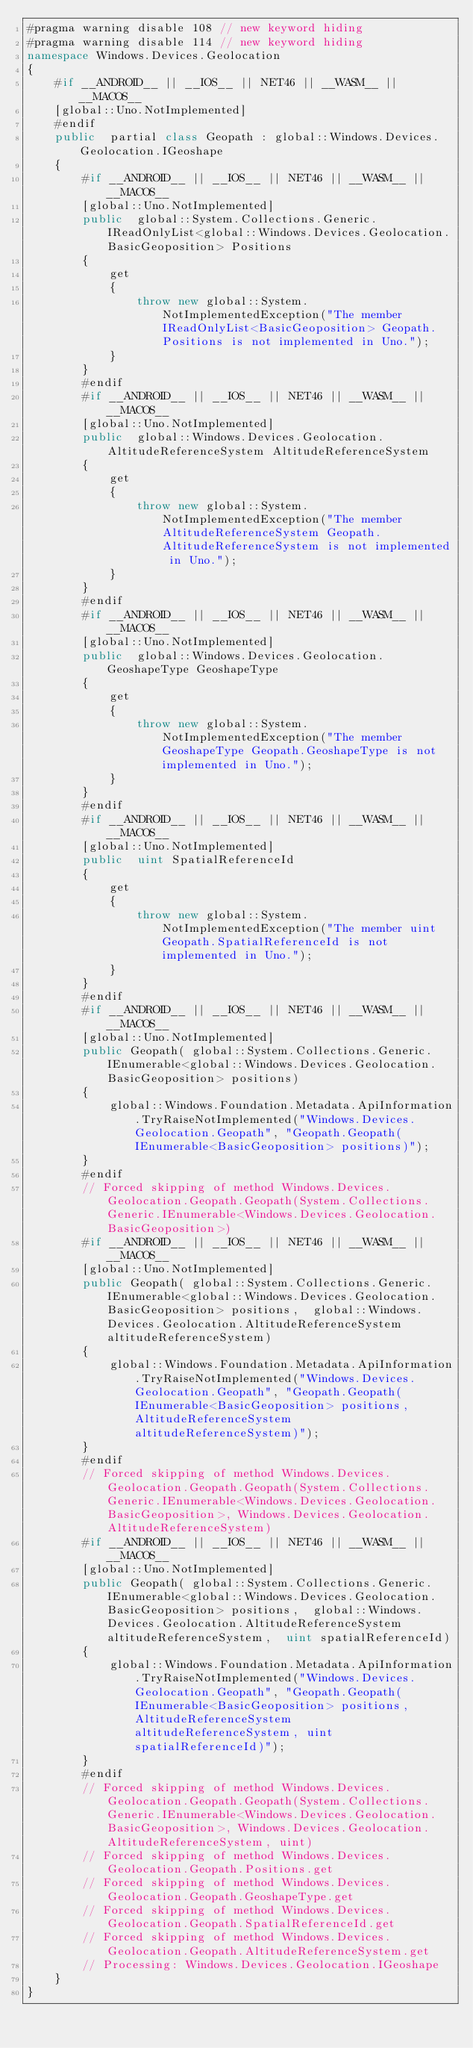Convert code to text. <code><loc_0><loc_0><loc_500><loc_500><_C#_>#pragma warning disable 108 // new keyword hiding
#pragma warning disable 114 // new keyword hiding
namespace Windows.Devices.Geolocation
{
	#if __ANDROID__ || __IOS__ || NET46 || __WASM__ || __MACOS__
	[global::Uno.NotImplemented]
	#endif
	public  partial class Geopath : global::Windows.Devices.Geolocation.IGeoshape
	{
		#if __ANDROID__ || __IOS__ || NET46 || __WASM__ || __MACOS__
		[global::Uno.NotImplemented]
		public  global::System.Collections.Generic.IReadOnlyList<global::Windows.Devices.Geolocation.BasicGeoposition> Positions
		{
			get
			{
				throw new global::System.NotImplementedException("The member IReadOnlyList<BasicGeoposition> Geopath.Positions is not implemented in Uno.");
			}
		}
		#endif
		#if __ANDROID__ || __IOS__ || NET46 || __WASM__ || __MACOS__
		[global::Uno.NotImplemented]
		public  global::Windows.Devices.Geolocation.AltitudeReferenceSystem AltitudeReferenceSystem
		{
			get
			{
				throw new global::System.NotImplementedException("The member AltitudeReferenceSystem Geopath.AltitudeReferenceSystem is not implemented in Uno.");
			}
		}
		#endif
		#if __ANDROID__ || __IOS__ || NET46 || __WASM__ || __MACOS__
		[global::Uno.NotImplemented]
		public  global::Windows.Devices.Geolocation.GeoshapeType GeoshapeType
		{
			get
			{
				throw new global::System.NotImplementedException("The member GeoshapeType Geopath.GeoshapeType is not implemented in Uno.");
			}
		}
		#endif
		#if __ANDROID__ || __IOS__ || NET46 || __WASM__ || __MACOS__
		[global::Uno.NotImplemented]
		public  uint SpatialReferenceId
		{
			get
			{
				throw new global::System.NotImplementedException("The member uint Geopath.SpatialReferenceId is not implemented in Uno.");
			}
		}
		#endif
		#if __ANDROID__ || __IOS__ || NET46 || __WASM__ || __MACOS__
		[global::Uno.NotImplemented]
		public Geopath( global::System.Collections.Generic.IEnumerable<global::Windows.Devices.Geolocation.BasicGeoposition> positions) 
		{
			global::Windows.Foundation.Metadata.ApiInformation.TryRaiseNotImplemented("Windows.Devices.Geolocation.Geopath", "Geopath.Geopath(IEnumerable<BasicGeoposition> positions)");
		}
		#endif
		// Forced skipping of method Windows.Devices.Geolocation.Geopath.Geopath(System.Collections.Generic.IEnumerable<Windows.Devices.Geolocation.BasicGeoposition>)
		#if __ANDROID__ || __IOS__ || NET46 || __WASM__ || __MACOS__
		[global::Uno.NotImplemented]
		public Geopath( global::System.Collections.Generic.IEnumerable<global::Windows.Devices.Geolocation.BasicGeoposition> positions,  global::Windows.Devices.Geolocation.AltitudeReferenceSystem altitudeReferenceSystem) 
		{
			global::Windows.Foundation.Metadata.ApiInformation.TryRaiseNotImplemented("Windows.Devices.Geolocation.Geopath", "Geopath.Geopath(IEnumerable<BasicGeoposition> positions, AltitudeReferenceSystem altitudeReferenceSystem)");
		}
		#endif
		// Forced skipping of method Windows.Devices.Geolocation.Geopath.Geopath(System.Collections.Generic.IEnumerable<Windows.Devices.Geolocation.BasicGeoposition>, Windows.Devices.Geolocation.AltitudeReferenceSystem)
		#if __ANDROID__ || __IOS__ || NET46 || __WASM__ || __MACOS__
		[global::Uno.NotImplemented]
		public Geopath( global::System.Collections.Generic.IEnumerable<global::Windows.Devices.Geolocation.BasicGeoposition> positions,  global::Windows.Devices.Geolocation.AltitudeReferenceSystem altitudeReferenceSystem,  uint spatialReferenceId) 
		{
			global::Windows.Foundation.Metadata.ApiInformation.TryRaiseNotImplemented("Windows.Devices.Geolocation.Geopath", "Geopath.Geopath(IEnumerable<BasicGeoposition> positions, AltitudeReferenceSystem altitudeReferenceSystem, uint spatialReferenceId)");
		}
		#endif
		// Forced skipping of method Windows.Devices.Geolocation.Geopath.Geopath(System.Collections.Generic.IEnumerable<Windows.Devices.Geolocation.BasicGeoposition>, Windows.Devices.Geolocation.AltitudeReferenceSystem, uint)
		// Forced skipping of method Windows.Devices.Geolocation.Geopath.Positions.get
		// Forced skipping of method Windows.Devices.Geolocation.Geopath.GeoshapeType.get
		// Forced skipping of method Windows.Devices.Geolocation.Geopath.SpatialReferenceId.get
		// Forced skipping of method Windows.Devices.Geolocation.Geopath.AltitudeReferenceSystem.get
		// Processing: Windows.Devices.Geolocation.IGeoshape
	}
}
</code> 